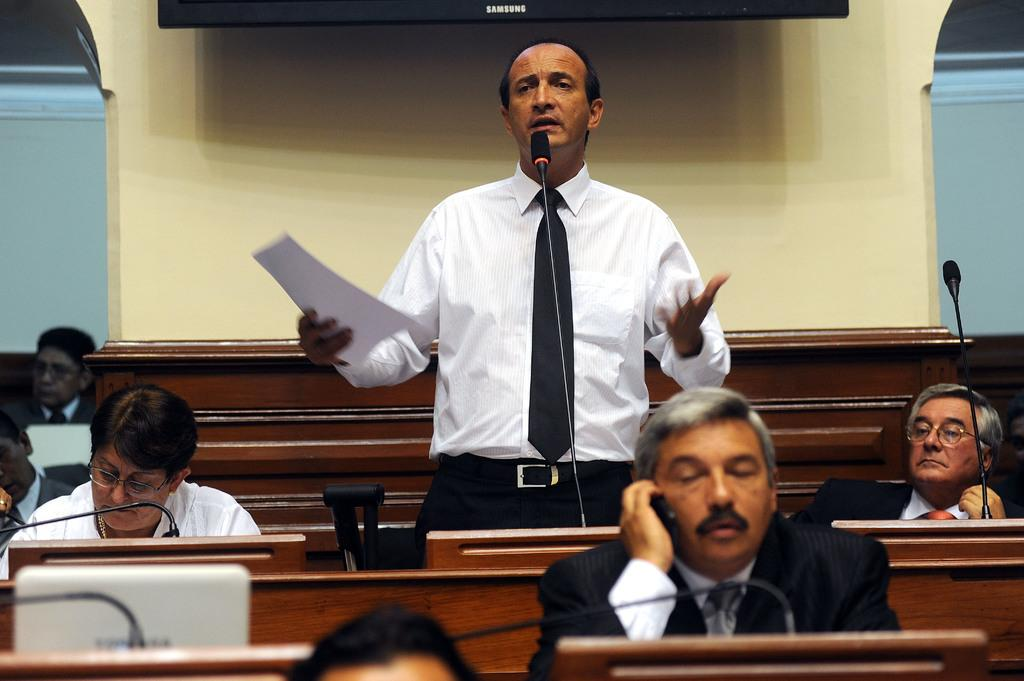How many people are in the image? There are people in the image, but the exact number is not specified. What type of furniture is present in the image? There are benches in the image. What is the background element in the image? There is a wall in the image. What objects can be seen in the image? There are objects in the image, but specific details are not provided. What electronic device is on a table in the image? There is a laptop on a table in the image. What communication devices are on a table in the image? There are mics on a table in the image. What is a person holding in the image? A person is standing and holding a paper in the image. What type of summer unit is being designed in the image? There is no mention of summer or a design unit in the image. 